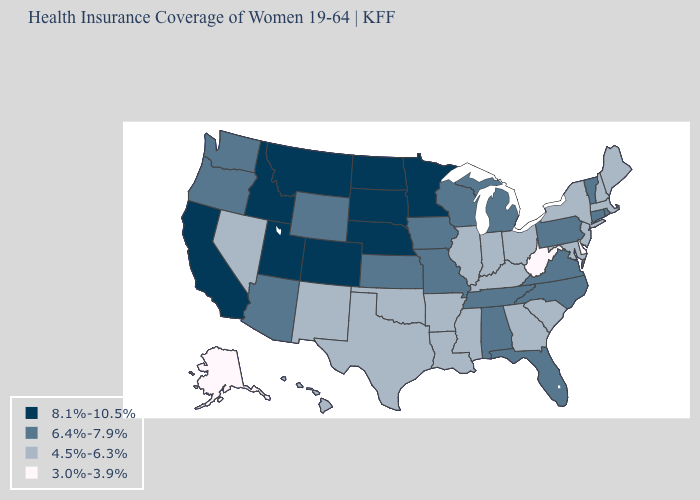What is the value of Kansas?
Concise answer only. 6.4%-7.9%. Name the states that have a value in the range 4.5%-6.3%?
Write a very short answer. Arkansas, Georgia, Hawaii, Illinois, Indiana, Kentucky, Louisiana, Maine, Maryland, Massachusetts, Mississippi, Nevada, New Hampshire, New Jersey, New Mexico, New York, Ohio, Oklahoma, South Carolina, Texas. What is the value of Alaska?
Keep it brief. 3.0%-3.9%. Does Washington have a lower value than Idaho?
Keep it brief. Yes. Does Alaska have the lowest value in the West?
Keep it brief. Yes. Among the states that border New Mexico , does Texas have the lowest value?
Concise answer only. Yes. Does Maryland have a lower value than Nevada?
Short answer required. No. Among the states that border California , which have the highest value?
Concise answer only. Arizona, Oregon. Among the states that border Delaware , which have the highest value?
Write a very short answer. Pennsylvania. What is the value of Massachusetts?
Keep it brief. 4.5%-6.3%. What is the value of Texas?
Concise answer only. 4.5%-6.3%. What is the highest value in the South ?
Quick response, please. 6.4%-7.9%. Does Illinois have a higher value than Delaware?
Short answer required. Yes. Does Vermont have the lowest value in the Northeast?
Give a very brief answer. No. Name the states that have a value in the range 8.1%-10.5%?
Be succinct. California, Colorado, Idaho, Minnesota, Montana, Nebraska, North Dakota, South Dakota, Utah. 